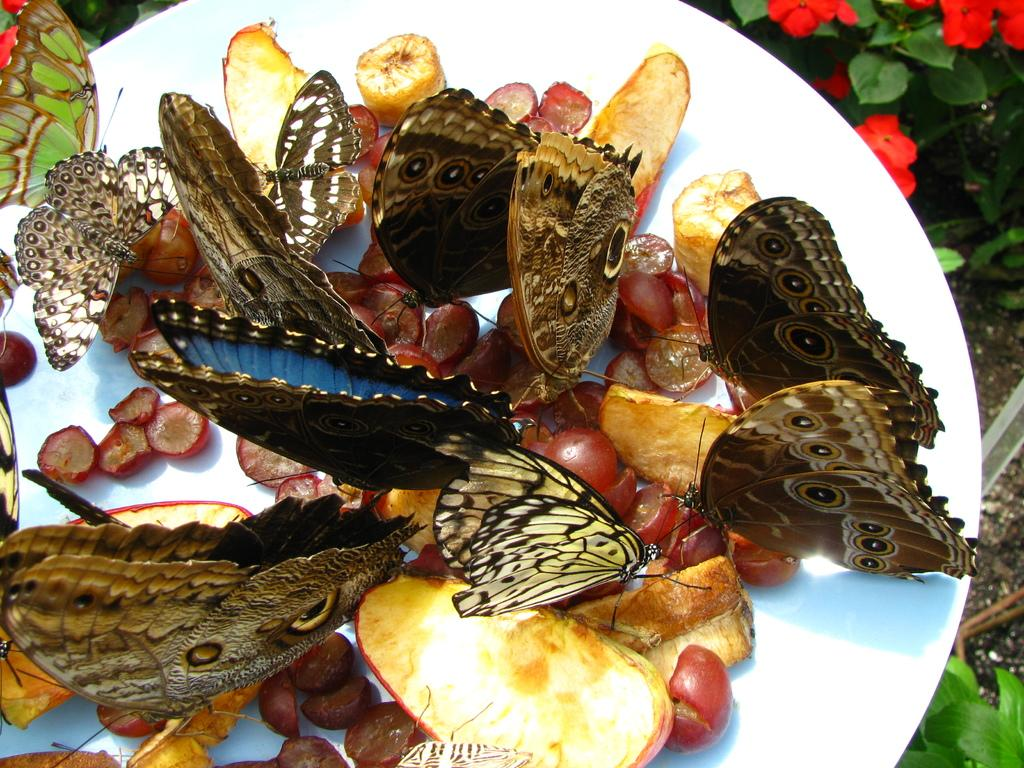What creatures can be seen in the image? There are butterflies in the image. What are the butterflies doing in the image? The butterflies are sitting on fruits. Where are the fruits located in the image? The fruits are on a plate. What type of vegetation is present in the image? There are flowers on a plant in the image. Can you tell me how many snails are crawling on the marble in the image? There is no marble or snails present in the image; it features butterflies sitting on fruits and flowers on a plant. 